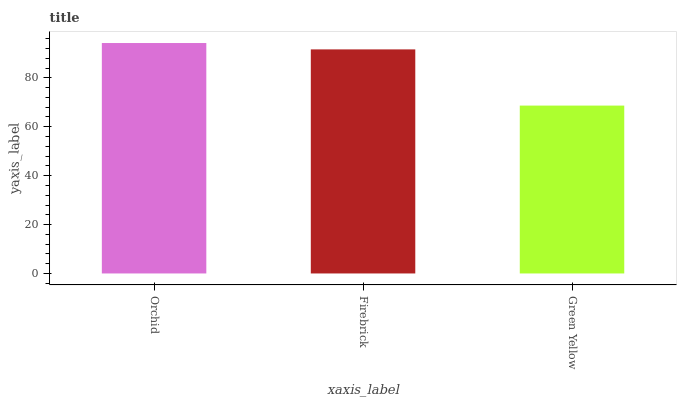Is Green Yellow the minimum?
Answer yes or no. Yes. Is Orchid the maximum?
Answer yes or no. Yes. Is Firebrick the minimum?
Answer yes or no. No. Is Firebrick the maximum?
Answer yes or no. No. Is Orchid greater than Firebrick?
Answer yes or no. Yes. Is Firebrick less than Orchid?
Answer yes or no. Yes. Is Firebrick greater than Orchid?
Answer yes or no. No. Is Orchid less than Firebrick?
Answer yes or no. No. Is Firebrick the high median?
Answer yes or no. Yes. Is Firebrick the low median?
Answer yes or no. Yes. Is Orchid the high median?
Answer yes or no. No. Is Orchid the low median?
Answer yes or no. No. 